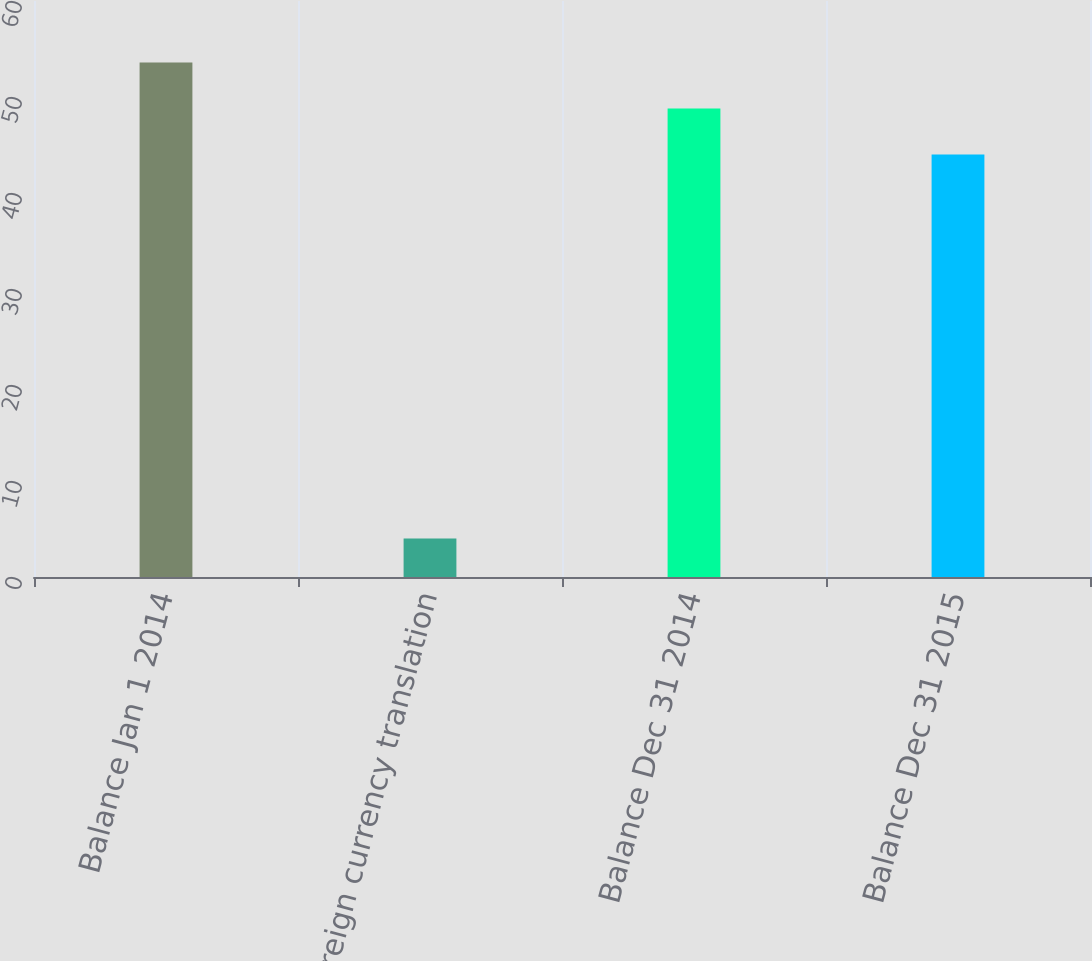Convert chart. <chart><loc_0><loc_0><loc_500><loc_500><bar_chart><fcel>Balance Jan 1 2014<fcel>Foreign currency translation<fcel>Balance Dec 31 2014<fcel>Balance Dec 31 2015<nl><fcel>53.6<fcel>4<fcel>48.8<fcel>44<nl></chart> 